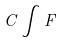<formula> <loc_0><loc_0><loc_500><loc_500>C \int F</formula> 